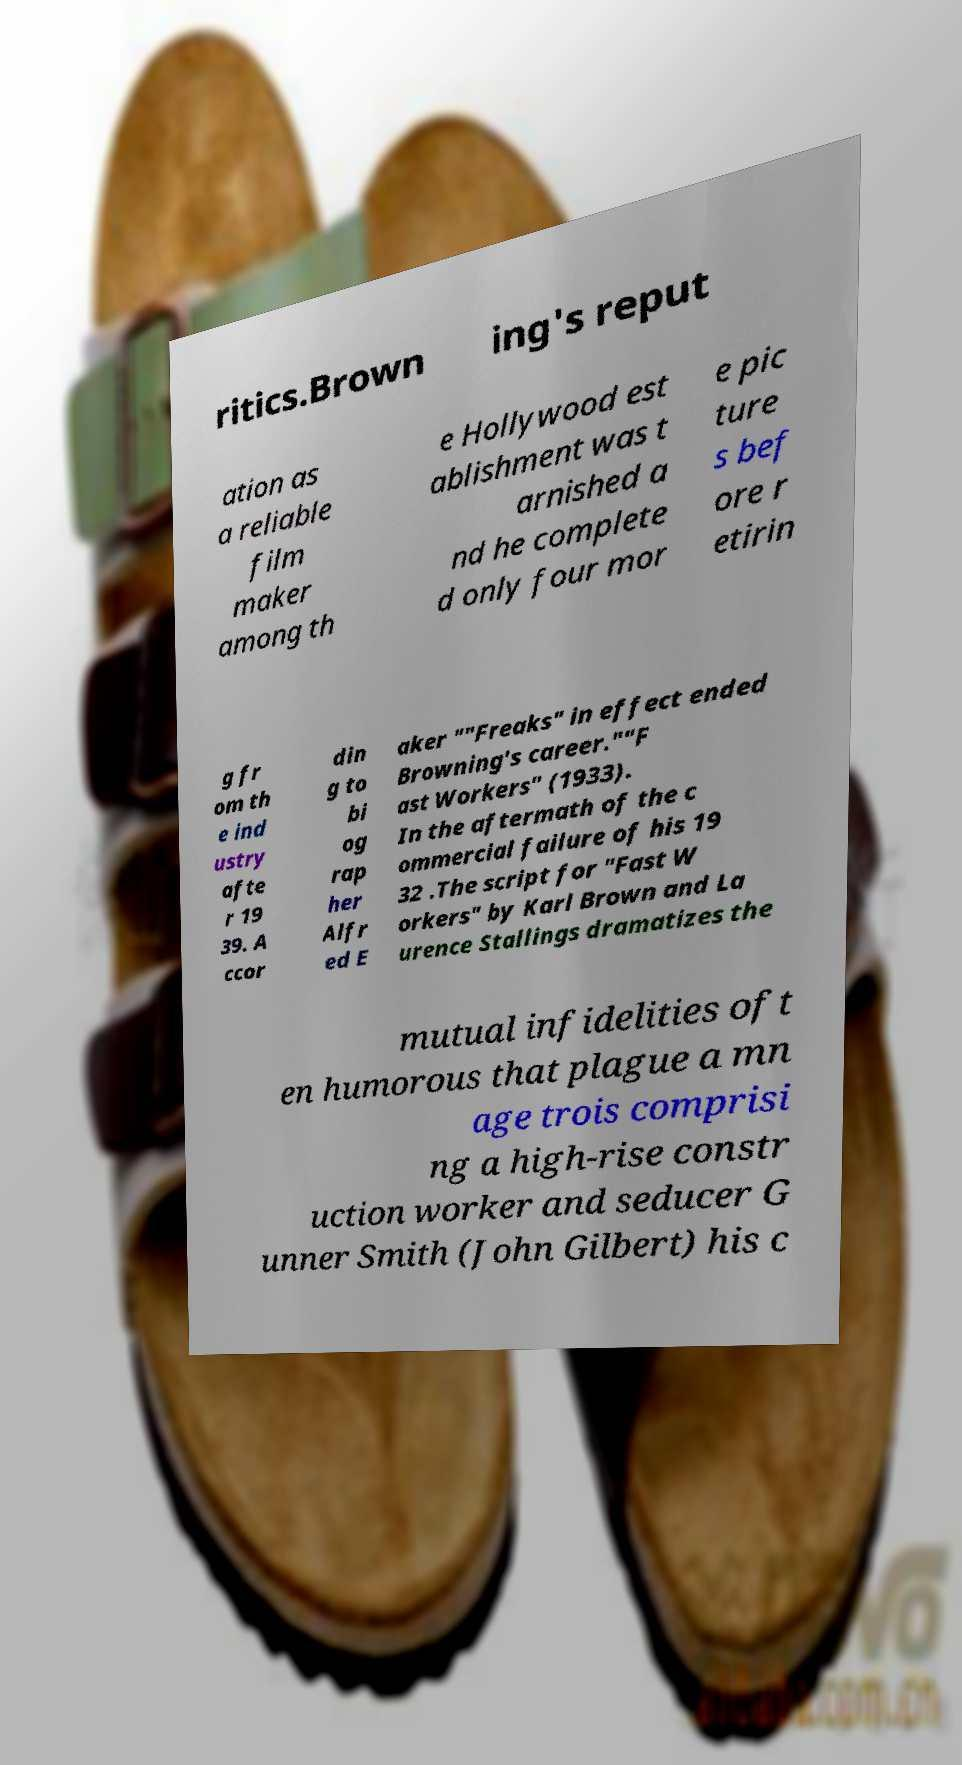What messages or text are displayed in this image? I need them in a readable, typed format. ritics.Brown ing's reput ation as a reliable film maker among th e Hollywood est ablishment was t arnished a nd he complete d only four mor e pic ture s bef ore r etirin g fr om th e ind ustry afte r 19 39. A ccor din g to bi og rap her Alfr ed E aker ""Freaks" in effect ended Browning's career.""F ast Workers" (1933). In the aftermath of the c ommercial failure of his 19 32 .The script for "Fast W orkers" by Karl Brown and La urence Stallings dramatizes the mutual infidelities oft en humorous that plague a mn age trois comprisi ng a high-rise constr uction worker and seducer G unner Smith (John Gilbert) his c 